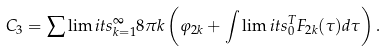<formula> <loc_0><loc_0><loc_500><loc_500>C _ { 3 } = \sum \lim i t s _ { k = 1 } ^ { \infty } 8 \pi k \left ( \varphi _ { 2 k } + \int \lim i t s _ { 0 } ^ { T } F _ { 2 k } ( \tau ) d \tau \right ) .</formula> 